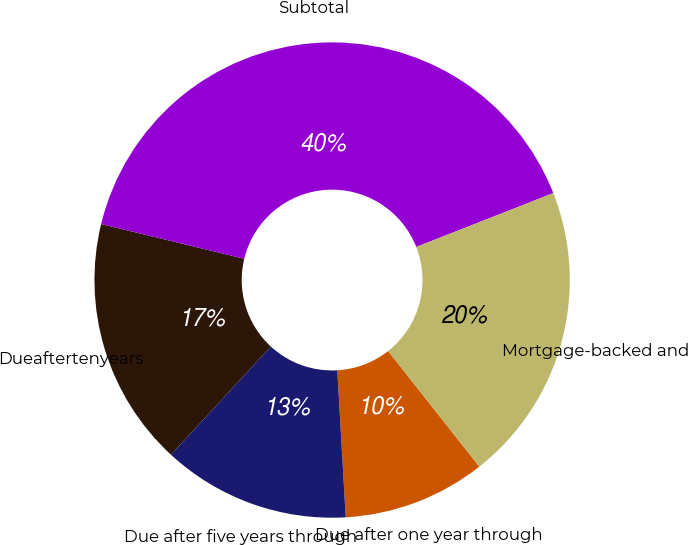Convert chart. <chart><loc_0><loc_0><loc_500><loc_500><pie_chart><fcel>Due after one year through<fcel>Due after five years through<fcel>Dueaftertenyears<fcel>Subtotal<fcel>Mortgage-backed and<nl><fcel>9.72%<fcel>12.77%<fcel>16.93%<fcel>40.25%<fcel>20.33%<nl></chart> 